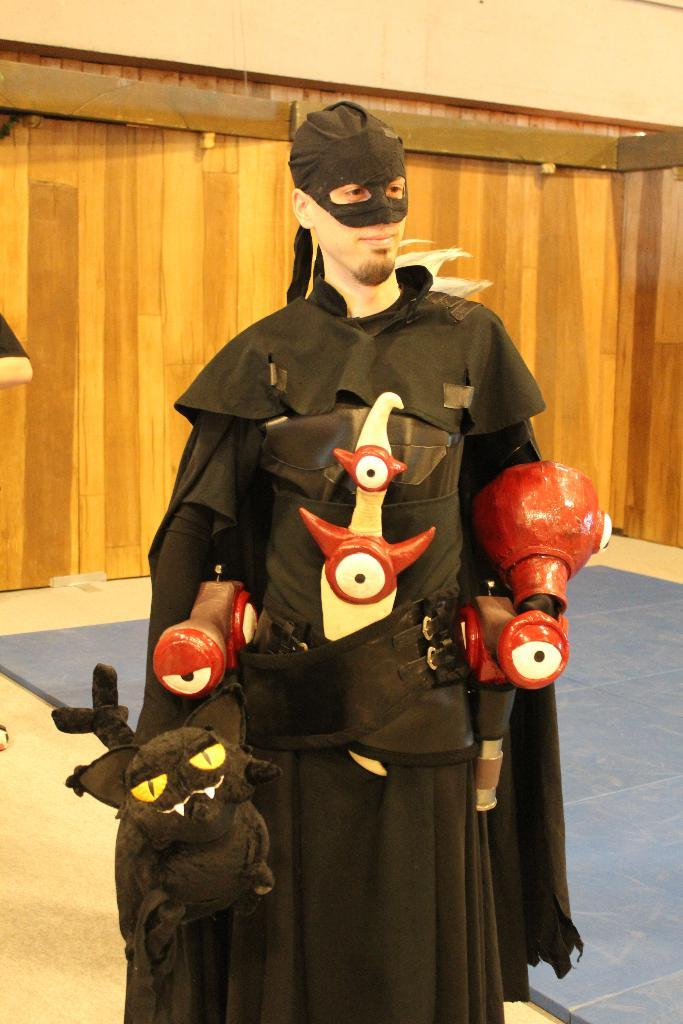What is the person in the image wearing? The person is wearing a costume in the image. What is the person holding in their hand? The person is holding a toy in their hand. What type of surface is visible beneath the person? There is a floor visible in the image. What material is used for the wall in the background? There is a wooden wall in the image. How many geese are visible in the image? There are no geese present in the image. What type of wool is used for the costume in the image? The provided facts do not mention the material used for the costume, so it cannot be determined from the image. 